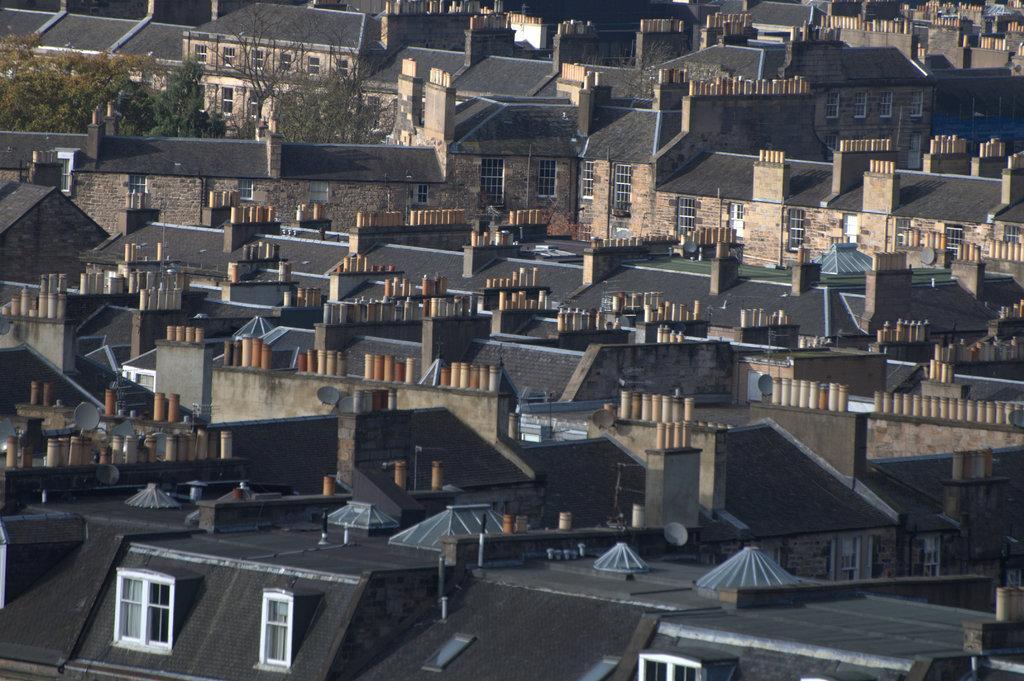Could you give a brief overview of what you see in this image? In this image I can see the roofs of buildings which are black in color and I can see few windows, few trees which are green in color and few other objects which are orange, cream and brown in color on the roofs. 